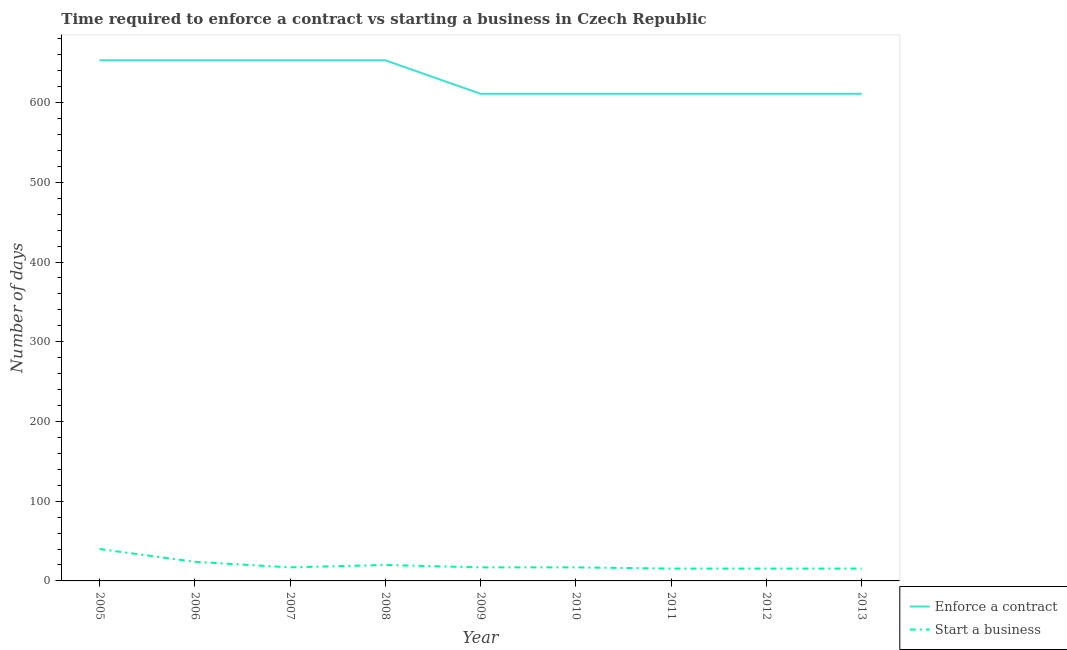Does the line corresponding to number of days to start a business intersect with the line corresponding to number of days to enforece a contract?
Give a very brief answer. No. What is the number of days to start a business in 2013?
Your answer should be very brief. 15.5. Across all years, what is the minimum number of days to enforece a contract?
Your answer should be compact. 611. In which year was the number of days to start a business minimum?
Give a very brief answer. 2011. What is the total number of days to enforece a contract in the graph?
Provide a succinct answer. 5667. What is the difference between the number of days to enforece a contract in 2011 and the number of days to start a business in 2012?
Ensure brevity in your answer.  595.5. What is the average number of days to enforece a contract per year?
Give a very brief answer. 629.67. In the year 2006, what is the difference between the number of days to start a business and number of days to enforece a contract?
Make the answer very short. -629. What is the ratio of the number of days to start a business in 2005 to that in 2008?
Keep it short and to the point. 2. Is the number of days to start a business in 2005 less than that in 2006?
Provide a succinct answer. No. What is the difference between the highest and the second highest number of days to enforece a contract?
Keep it short and to the point. 0. What is the difference between the highest and the lowest number of days to enforece a contract?
Offer a very short reply. 42. Is the sum of the number of days to enforece a contract in 2008 and 2011 greater than the maximum number of days to start a business across all years?
Provide a short and direct response. Yes. Is the number of days to start a business strictly greater than the number of days to enforece a contract over the years?
Offer a terse response. No. Is the number of days to start a business strictly less than the number of days to enforece a contract over the years?
Provide a short and direct response. Yes. How many lines are there?
Provide a short and direct response. 2. How many years are there in the graph?
Your answer should be very brief. 9. What is the title of the graph?
Provide a short and direct response. Time required to enforce a contract vs starting a business in Czech Republic. What is the label or title of the Y-axis?
Ensure brevity in your answer.  Number of days. What is the Number of days of Enforce a contract in 2005?
Offer a very short reply. 653. What is the Number of days in Start a business in 2005?
Provide a short and direct response. 40. What is the Number of days of Enforce a contract in 2006?
Your response must be concise. 653. What is the Number of days of Start a business in 2006?
Offer a very short reply. 24. What is the Number of days of Enforce a contract in 2007?
Your response must be concise. 653. What is the Number of days of Start a business in 2007?
Provide a succinct answer. 17. What is the Number of days in Enforce a contract in 2008?
Ensure brevity in your answer.  653. What is the Number of days in Start a business in 2008?
Your answer should be compact. 20. What is the Number of days of Enforce a contract in 2009?
Keep it short and to the point. 611. What is the Number of days of Enforce a contract in 2010?
Provide a succinct answer. 611. What is the Number of days of Enforce a contract in 2011?
Offer a very short reply. 611. What is the Number of days of Start a business in 2011?
Make the answer very short. 15.5. What is the Number of days in Enforce a contract in 2012?
Provide a succinct answer. 611. What is the Number of days in Start a business in 2012?
Provide a short and direct response. 15.5. What is the Number of days of Enforce a contract in 2013?
Ensure brevity in your answer.  611. What is the Number of days of Start a business in 2013?
Give a very brief answer. 15.5. Across all years, what is the maximum Number of days of Enforce a contract?
Your answer should be very brief. 653. Across all years, what is the maximum Number of days of Start a business?
Offer a terse response. 40. Across all years, what is the minimum Number of days of Enforce a contract?
Offer a terse response. 611. Across all years, what is the minimum Number of days in Start a business?
Provide a succinct answer. 15.5. What is the total Number of days of Enforce a contract in the graph?
Give a very brief answer. 5667. What is the total Number of days of Start a business in the graph?
Keep it short and to the point. 181.5. What is the difference between the Number of days in Start a business in 2005 and that in 2006?
Your answer should be compact. 16. What is the difference between the Number of days in Enforce a contract in 2005 and that in 2007?
Offer a terse response. 0. What is the difference between the Number of days of Start a business in 2005 and that in 2007?
Give a very brief answer. 23. What is the difference between the Number of days of Enforce a contract in 2005 and that in 2008?
Offer a terse response. 0. What is the difference between the Number of days of Enforce a contract in 2005 and that in 2009?
Provide a short and direct response. 42. What is the difference between the Number of days of Enforce a contract in 2005 and that in 2010?
Offer a very short reply. 42. What is the difference between the Number of days in Start a business in 2005 and that in 2010?
Keep it short and to the point. 23. What is the difference between the Number of days in Enforce a contract in 2005 and that in 2011?
Offer a terse response. 42. What is the difference between the Number of days of Start a business in 2005 and that in 2011?
Give a very brief answer. 24.5. What is the difference between the Number of days in Enforce a contract in 2005 and that in 2012?
Your answer should be very brief. 42. What is the difference between the Number of days of Start a business in 2005 and that in 2013?
Make the answer very short. 24.5. What is the difference between the Number of days in Start a business in 2006 and that in 2007?
Offer a very short reply. 7. What is the difference between the Number of days of Enforce a contract in 2006 and that in 2008?
Your response must be concise. 0. What is the difference between the Number of days of Start a business in 2006 and that in 2008?
Offer a terse response. 4. What is the difference between the Number of days of Start a business in 2006 and that in 2009?
Offer a terse response. 7. What is the difference between the Number of days in Enforce a contract in 2006 and that in 2010?
Offer a very short reply. 42. What is the difference between the Number of days in Start a business in 2006 and that in 2010?
Provide a succinct answer. 7. What is the difference between the Number of days of Start a business in 2006 and that in 2011?
Keep it short and to the point. 8.5. What is the difference between the Number of days in Enforce a contract in 2006 and that in 2012?
Provide a succinct answer. 42. What is the difference between the Number of days in Start a business in 2006 and that in 2012?
Offer a very short reply. 8.5. What is the difference between the Number of days of Enforce a contract in 2006 and that in 2013?
Offer a very short reply. 42. What is the difference between the Number of days of Start a business in 2006 and that in 2013?
Ensure brevity in your answer.  8.5. What is the difference between the Number of days in Start a business in 2007 and that in 2008?
Your answer should be compact. -3. What is the difference between the Number of days in Enforce a contract in 2007 and that in 2009?
Your response must be concise. 42. What is the difference between the Number of days of Enforce a contract in 2007 and that in 2010?
Offer a very short reply. 42. What is the difference between the Number of days in Enforce a contract in 2007 and that in 2011?
Your answer should be compact. 42. What is the difference between the Number of days in Enforce a contract in 2007 and that in 2012?
Make the answer very short. 42. What is the difference between the Number of days of Enforce a contract in 2008 and that in 2009?
Ensure brevity in your answer.  42. What is the difference between the Number of days in Start a business in 2008 and that in 2009?
Your answer should be compact. 3. What is the difference between the Number of days of Enforce a contract in 2008 and that in 2010?
Provide a succinct answer. 42. What is the difference between the Number of days of Start a business in 2008 and that in 2010?
Your answer should be very brief. 3. What is the difference between the Number of days of Start a business in 2008 and that in 2011?
Your answer should be compact. 4.5. What is the difference between the Number of days of Enforce a contract in 2008 and that in 2013?
Keep it short and to the point. 42. What is the difference between the Number of days of Enforce a contract in 2009 and that in 2010?
Provide a succinct answer. 0. What is the difference between the Number of days in Start a business in 2009 and that in 2010?
Your answer should be very brief. 0. What is the difference between the Number of days of Enforce a contract in 2009 and that in 2012?
Your response must be concise. 0. What is the difference between the Number of days in Enforce a contract in 2009 and that in 2013?
Offer a terse response. 0. What is the difference between the Number of days of Start a business in 2009 and that in 2013?
Provide a short and direct response. 1.5. What is the difference between the Number of days of Enforce a contract in 2010 and that in 2011?
Offer a very short reply. 0. What is the difference between the Number of days of Start a business in 2010 and that in 2013?
Your answer should be very brief. 1.5. What is the difference between the Number of days in Enforce a contract in 2011 and that in 2012?
Your answer should be very brief. 0. What is the difference between the Number of days of Start a business in 2011 and that in 2012?
Offer a very short reply. 0. What is the difference between the Number of days in Start a business in 2012 and that in 2013?
Provide a short and direct response. 0. What is the difference between the Number of days of Enforce a contract in 2005 and the Number of days of Start a business in 2006?
Provide a short and direct response. 629. What is the difference between the Number of days in Enforce a contract in 2005 and the Number of days in Start a business in 2007?
Your response must be concise. 636. What is the difference between the Number of days in Enforce a contract in 2005 and the Number of days in Start a business in 2008?
Provide a short and direct response. 633. What is the difference between the Number of days in Enforce a contract in 2005 and the Number of days in Start a business in 2009?
Keep it short and to the point. 636. What is the difference between the Number of days in Enforce a contract in 2005 and the Number of days in Start a business in 2010?
Your answer should be very brief. 636. What is the difference between the Number of days in Enforce a contract in 2005 and the Number of days in Start a business in 2011?
Offer a terse response. 637.5. What is the difference between the Number of days of Enforce a contract in 2005 and the Number of days of Start a business in 2012?
Your response must be concise. 637.5. What is the difference between the Number of days in Enforce a contract in 2005 and the Number of days in Start a business in 2013?
Your answer should be very brief. 637.5. What is the difference between the Number of days of Enforce a contract in 2006 and the Number of days of Start a business in 2007?
Ensure brevity in your answer.  636. What is the difference between the Number of days of Enforce a contract in 2006 and the Number of days of Start a business in 2008?
Ensure brevity in your answer.  633. What is the difference between the Number of days in Enforce a contract in 2006 and the Number of days in Start a business in 2009?
Make the answer very short. 636. What is the difference between the Number of days in Enforce a contract in 2006 and the Number of days in Start a business in 2010?
Your answer should be compact. 636. What is the difference between the Number of days of Enforce a contract in 2006 and the Number of days of Start a business in 2011?
Provide a succinct answer. 637.5. What is the difference between the Number of days of Enforce a contract in 2006 and the Number of days of Start a business in 2012?
Offer a terse response. 637.5. What is the difference between the Number of days in Enforce a contract in 2006 and the Number of days in Start a business in 2013?
Ensure brevity in your answer.  637.5. What is the difference between the Number of days in Enforce a contract in 2007 and the Number of days in Start a business in 2008?
Offer a very short reply. 633. What is the difference between the Number of days in Enforce a contract in 2007 and the Number of days in Start a business in 2009?
Ensure brevity in your answer.  636. What is the difference between the Number of days of Enforce a contract in 2007 and the Number of days of Start a business in 2010?
Give a very brief answer. 636. What is the difference between the Number of days of Enforce a contract in 2007 and the Number of days of Start a business in 2011?
Your answer should be compact. 637.5. What is the difference between the Number of days in Enforce a contract in 2007 and the Number of days in Start a business in 2012?
Give a very brief answer. 637.5. What is the difference between the Number of days in Enforce a contract in 2007 and the Number of days in Start a business in 2013?
Offer a very short reply. 637.5. What is the difference between the Number of days in Enforce a contract in 2008 and the Number of days in Start a business in 2009?
Keep it short and to the point. 636. What is the difference between the Number of days of Enforce a contract in 2008 and the Number of days of Start a business in 2010?
Your answer should be compact. 636. What is the difference between the Number of days of Enforce a contract in 2008 and the Number of days of Start a business in 2011?
Offer a terse response. 637.5. What is the difference between the Number of days of Enforce a contract in 2008 and the Number of days of Start a business in 2012?
Provide a succinct answer. 637.5. What is the difference between the Number of days in Enforce a contract in 2008 and the Number of days in Start a business in 2013?
Your answer should be compact. 637.5. What is the difference between the Number of days of Enforce a contract in 2009 and the Number of days of Start a business in 2010?
Your answer should be compact. 594. What is the difference between the Number of days of Enforce a contract in 2009 and the Number of days of Start a business in 2011?
Ensure brevity in your answer.  595.5. What is the difference between the Number of days in Enforce a contract in 2009 and the Number of days in Start a business in 2012?
Your response must be concise. 595.5. What is the difference between the Number of days of Enforce a contract in 2009 and the Number of days of Start a business in 2013?
Offer a very short reply. 595.5. What is the difference between the Number of days of Enforce a contract in 2010 and the Number of days of Start a business in 2011?
Offer a terse response. 595.5. What is the difference between the Number of days in Enforce a contract in 2010 and the Number of days in Start a business in 2012?
Provide a succinct answer. 595.5. What is the difference between the Number of days of Enforce a contract in 2010 and the Number of days of Start a business in 2013?
Keep it short and to the point. 595.5. What is the difference between the Number of days in Enforce a contract in 2011 and the Number of days in Start a business in 2012?
Offer a terse response. 595.5. What is the difference between the Number of days of Enforce a contract in 2011 and the Number of days of Start a business in 2013?
Your response must be concise. 595.5. What is the difference between the Number of days in Enforce a contract in 2012 and the Number of days in Start a business in 2013?
Your answer should be very brief. 595.5. What is the average Number of days of Enforce a contract per year?
Give a very brief answer. 629.67. What is the average Number of days in Start a business per year?
Keep it short and to the point. 20.17. In the year 2005, what is the difference between the Number of days of Enforce a contract and Number of days of Start a business?
Provide a short and direct response. 613. In the year 2006, what is the difference between the Number of days of Enforce a contract and Number of days of Start a business?
Your answer should be very brief. 629. In the year 2007, what is the difference between the Number of days in Enforce a contract and Number of days in Start a business?
Give a very brief answer. 636. In the year 2008, what is the difference between the Number of days in Enforce a contract and Number of days in Start a business?
Your response must be concise. 633. In the year 2009, what is the difference between the Number of days in Enforce a contract and Number of days in Start a business?
Provide a succinct answer. 594. In the year 2010, what is the difference between the Number of days of Enforce a contract and Number of days of Start a business?
Your response must be concise. 594. In the year 2011, what is the difference between the Number of days in Enforce a contract and Number of days in Start a business?
Ensure brevity in your answer.  595.5. In the year 2012, what is the difference between the Number of days in Enforce a contract and Number of days in Start a business?
Keep it short and to the point. 595.5. In the year 2013, what is the difference between the Number of days in Enforce a contract and Number of days in Start a business?
Your answer should be compact. 595.5. What is the ratio of the Number of days in Enforce a contract in 2005 to that in 2006?
Give a very brief answer. 1. What is the ratio of the Number of days of Start a business in 2005 to that in 2006?
Offer a very short reply. 1.67. What is the ratio of the Number of days in Start a business in 2005 to that in 2007?
Your answer should be compact. 2.35. What is the ratio of the Number of days of Start a business in 2005 to that in 2008?
Your answer should be very brief. 2. What is the ratio of the Number of days of Enforce a contract in 2005 to that in 2009?
Give a very brief answer. 1.07. What is the ratio of the Number of days of Start a business in 2005 to that in 2009?
Provide a succinct answer. 2.35. What is the ratio of the Number of days of Enforce a contract in 2005 to that in 2010?
Provide a succinct answer. 1.07. What is the ratio of the Number of days in Start a business in 2005 to that in 2010?
Your answer should be compact. 2.35. What is the ratio of the Number of days of Enforce a contract in 2005 to that in 2011?
Your response must be concise. 1.07. What is the ratio of the Number of days in Start a business in 2005 to that in 2011?
Keep it short and to the point. 2.58. What is the ratio of the Number of days in Enforce a contract in 2005 to that in 2012?
Provide a succinct answer. 1.07. What is the ratio of the Number of days in Start a business in 2005 to that in 2012?
Ensure brevity in your answer.  2.58. What is the ratio of the Number of days of Enforce a contract in 2005 to that in 2013?
Provide a succinct answer. 1.07. What is the ratio of the Number of days of Start a business in 2005 to that in 2013?
Keep it short and to the point. 2.58. What is the ratio of the Number of days of Enforce a contract in 2006 to that in 2007?
Give a very brief answer. 1. What is the ratio of the Number of days of Start a business in 2006 to that in 2007?
Make the answer very short. 1.41. What is the ratio of the Number of days of Enforce a contract in 2006 to that in 2008?
Ensure brevity in your answer.  1. What is the ratio of the Number of days of Start a business in 2006 to that in 2008?
Keep it short and to the point. 1.2. What is the ratio of the Number of days of Enforce a contract in 2006 to that in 2009?
Ensure brevity in your answer.  1.07. What is the ratio of the Number of days in Start a business in 2006 to that in 2009?
Your response must be concise. 1.41. What is the ratio of the Number of days in Enforce a contract in 2006 to that in 2010?
Make the answer very short. 1.07. What is the ratio of the Number of days in Start a business in 2006 to that in 2010?
Provide a succinct answer. 1.41. What is the ratio of the Number of days of Enforce a contract in 2006 to that in 2011?
Give a very brief answer. 1.07. What is the ratio of the Number of days in Start a business in 2006 to that in 2011?
Your answer should be very brief. 1.55. What is the ratio of the Number of days of Enforce a contract in 2006 to that in 2012?
Offer a very short reply. 1.07. What is the ratio of the Number of days in Start a business in 2006 to that in 2012?
Offer a very short reply. 1.55. What is the ratio of the Number of days in Enforce a contract in 2006 to that in 2013?
Keep it short and to the point. 1.07. What is the ratio of the Number of days in Start a business in 2006 to that in 2013?
Provide a short and direct response. 1.55. What is the ratio of the Number of days in Enforce a contract in 2007 to that in 2008?
Keep it short and to the point. 1. What is the ratio of the Number of days in Enforce a contract in 2007 to that in 2009?
Your response must be concise. 1.07. What is the ratio of the Number of days in Enforce a contract in 2007 to that in 2010?
Offer a very short reply. 1.07. What is the ratio of the Number of days of Start a business in 2007 to that in 2010?
Your answer should be very brief. 1. What is the ratio of the Number of days in Enforce a contract in 2007 to that in 2011?
Keep it short and to the point. 1.07. What is the ratio of the Number of days of Start a business in 2007 to that in 2011?
Provide a succinct answer. 1.1. What is the ratio of the Number of days in Enforce a contract in 2007 to that in 2012?
Your response must be concise. 1.07. What is the ratio of the Number of days in Start a business in 2007 to that in 2012?
Make the answer very short. 1.1. What is the ratio of the Number of days of Enforce a contract in 2007 to that in 2013?
Provide a succinct answer. 1.07. What is the ratio of the Number of days in Start a business in 2007 to that in 2013?
Your answer should be compact. 1.1. What is the ratio of the Number of days in Enforce a contract in 2008 to that in 2009?
Ensure brevity in your answer.  1.07. What is the ratio of the Number of days in Start a business in 2008 to that in 2009?
Your response must be concise. 1.18. What is the ratio of the Number of days in Enforce a contract in 2008 to that in 2010?
Make the answer very short. 1.07. What is the ratio of the Number of days of Start a business in 2008 to that in 2010?
Offer a very short reply. 1.18. What is the ratio of the Number of days of Enforce a contract in 2008 to that in 2011?
Give a very brief answer. 1.07. What is the ratio of the Number of days in Start a business in 2008 to that in 2011?
Give a very brief answer. 1.29. What is the ratio of the Number of days of Enforce a contract in 2008 to that in 2012?
Make the answer very short. 1.07. What is the ratio of the Number of days of Start a business in 2008 to that in 2012?
Ensure brevity in your answer.  1.29. What is the ratio of the Number of days of Enforce a contract in 2008 to that in 2013?
Offer a very short reply. 1.07. What is the ratio of the Number of days of Start a business in 2008 to that in 2013?
Keep it short and to the point. 1.29. What is the ratio of the Number of days of Enforce a contract in 2009 to that in 2010?
Offer a terse response. 1. What is the ratio of the Number of days in Enforce a contract in 2009 to that in 2011?
Your response must be concise. 1. What is the ratio of the Number of days in Start a business in 2009 to that in 2011?
Keep it short and to the point. 1.1. What is the ratio of the Number of days of Enforce a contract in 2009 to that in 2012?
Make the answer very short. 1. What is the ratio of the Number of days of Start a business in 2009 to that in 2012?
Provide a succinct answer. 1.1. What is the ratio of the Number of days of Enforce a contract in 2009 to that in 2013?
Provide a succinct answer. 1. What is the ratio of the Number of days of Start a business in 2009 to that in 2013?
Your answer should be very brief. 1.1. What is the ratio of the Number of days of Start a business in 2010 to that in 2011?
Give a very brief answer. 1.1. What is the ratio of the Number of days in Enforce a contract in 2010 to that in 2012?
Your response must be concise. 1. What is the ratio of the Number of days in Start a business in 2010 to that in 2012?
Make the answer very short. 1.1. What is the ratio of the Number of days of Enforce a contract in 2010 to that in 2013?
Your answer should be very brief. 1. What is the ratio of the Number of days of Start a business in 2010 to that in 2013?
Your answer should be compact. 1.1. What is the ratio of the Number of days of Enforce a contract in 2011 to that in 2013?
Offer a very short reply. 1. What is the ratio of the Number of days in Enforce a contract in 2012 to that in 2013?
Offer a very short reply. 1. What is the ratio of the Number of days in Start a business in 2012 to that in 2013?
Ensure brevity in your answer.  1. What is the difference between the highest and the second highest Number of days in Enforce a contract?
Your answer should be very brief. 0. What is the difference between the highest and the second highest Number of days in Start a business?
Provide a succinct answer. 16. What is the difference between the highest and the lowest Number of days of Enforce a contract?
Keep it short and to the point. 42. What is the difference between the highest and the lowest Number of days of Start a business?
Provide a short and direct response. 24.5. 